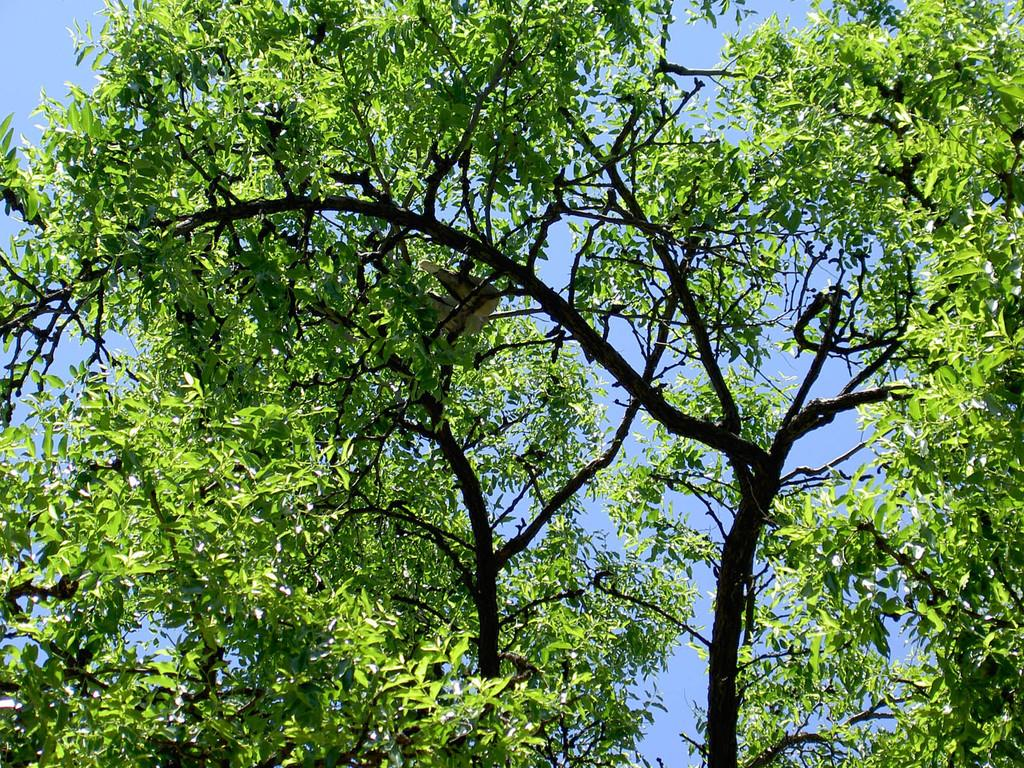What is the main subject in the center of the image? There is a group of trees in the center of the image. What can be seen in the background of the image? There is sky visible in the background of the image. What direction is the sheet blowing in the image? There is no sheet present in the image, so it is not possible to determine the direction in which it might be blowing. 